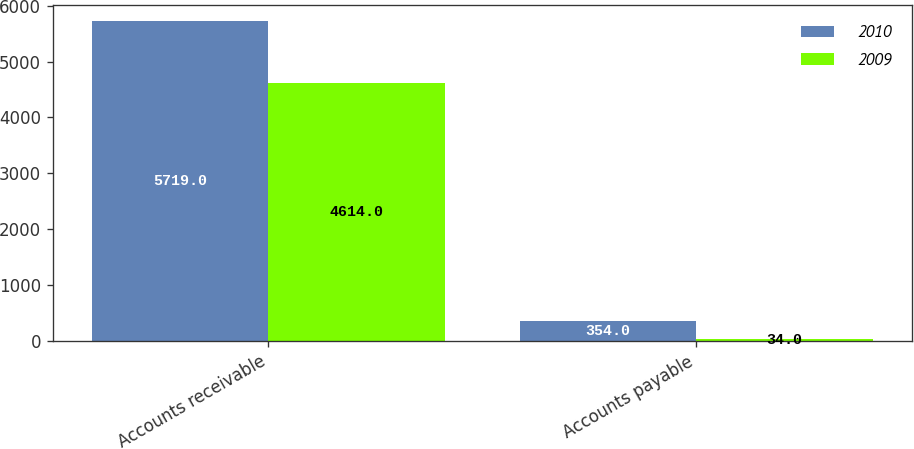<chart> <loc_0><loc_0><loc_500><loc_500><stacked_bar_chart><ecel><fcel>Accounts receivable<fcel>Accounts payable<nl><fcel>2010<fcel>5719<fcel>354<nl><fcel>2009<fcel>4614<fcel>34<nl></chart> 